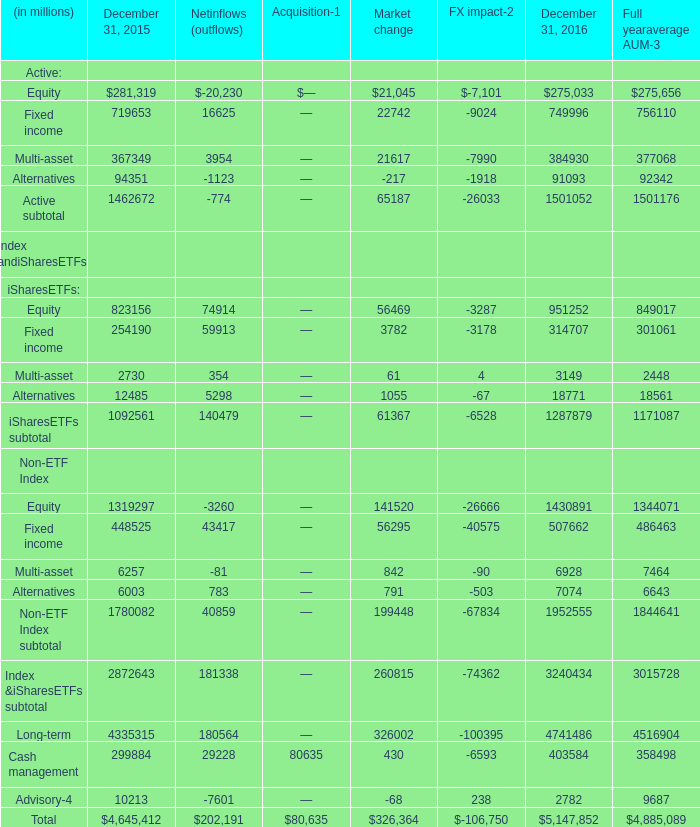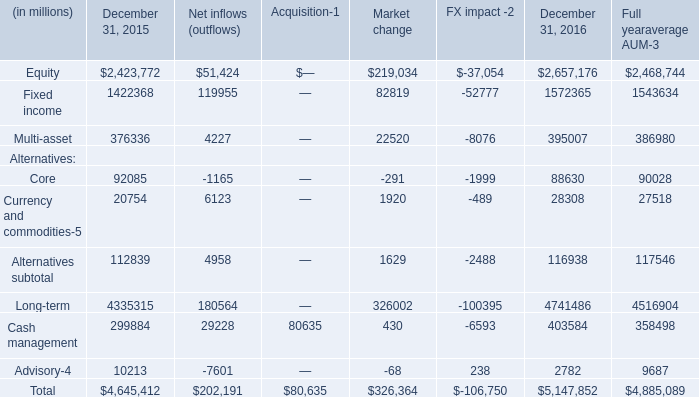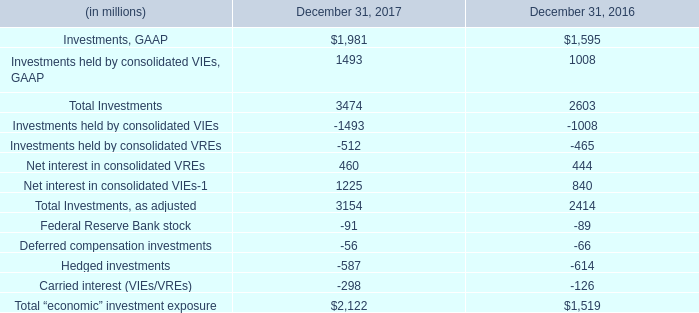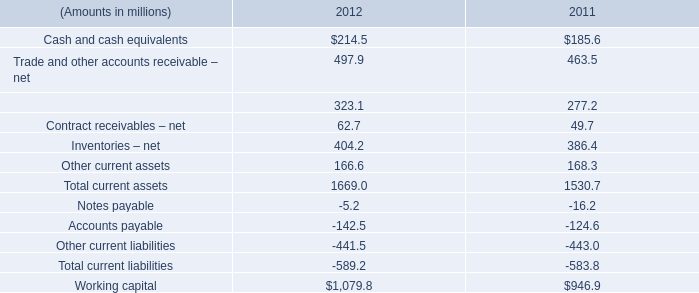What's the average of equity and fixed income and multi-asset in 2015? (in million) 
Computations: (((2423772 + 1422368) + 376336) / 3)
Answer: 1407492.0. 